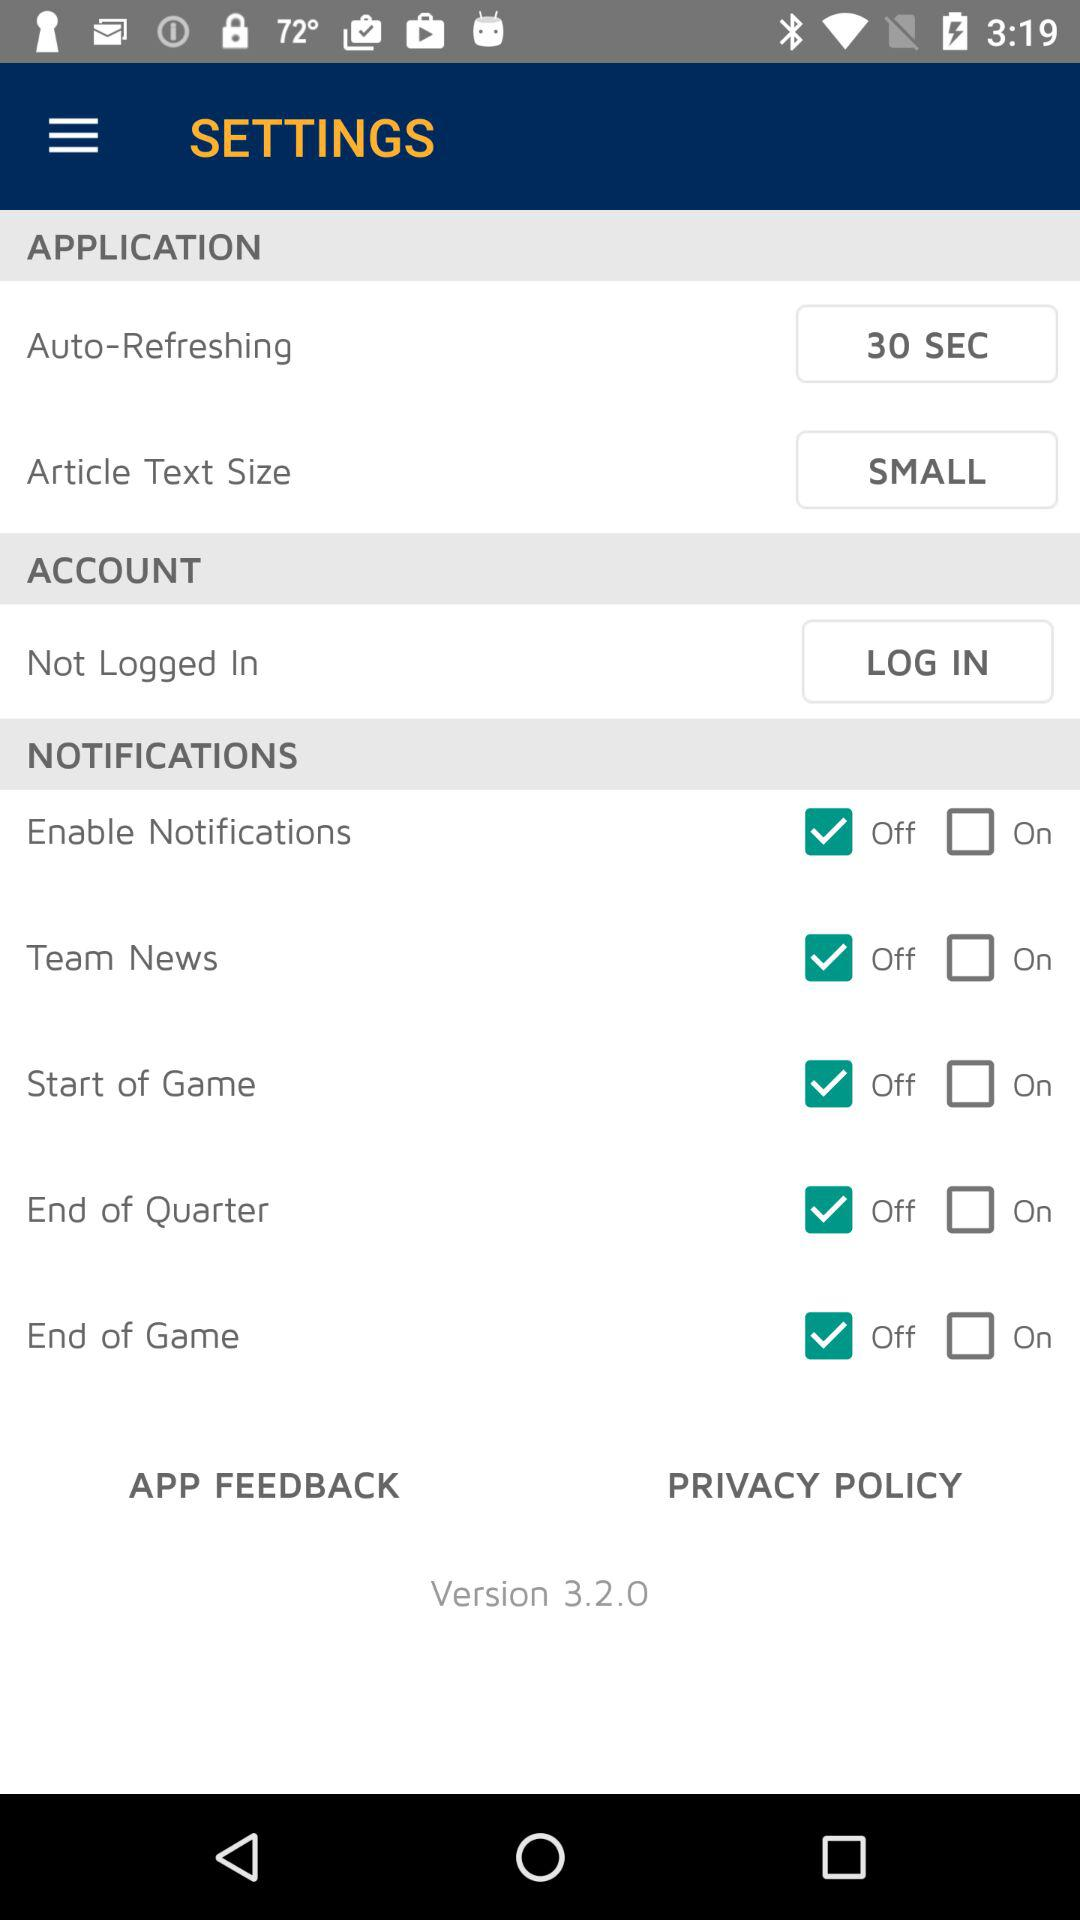What is the status of the "Enable Notifications" setting? The status is "off". 